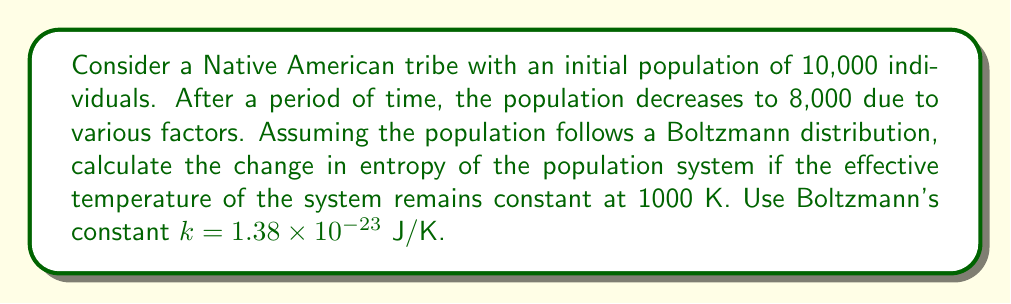Give your solution to this math problem. To solve this problem, we'll use the Boltzmann entropy formula and calculate the change in entropy:

1. The Boltzmann entropy formula is:
   $S = k \ln W$
   where $S$ is entropy, $k$ is Boltzmann's constant, and $W$ is the number of microstates (in this case, the population size).

2. Calculate the initial entropy:
   $S_1 = k \ln W_1 = (1.38 \times 10^{-23}) \ln(10000) = 1.27 \times 10^{-19}$ J/K

3. Calculate the final entropy:
   $S_2 = k \ln W_2 = (1.38 \times 10^{-23}) \ln(8000) = 1.25 \times 10^{-19}$ J/K

4. Calculate the change in entropy:
   $\Delta S = S_2 - S_1 = (1.25 \times 10^{-19}) - (1.27 \times 10^{-19}) = -2 \times 10^{-21}$ J/K

The negative value indicates a decrease in entropy, which is consistent with the decrease in population size.
Answer: $-2 \times 10^{-21}$ J/K 